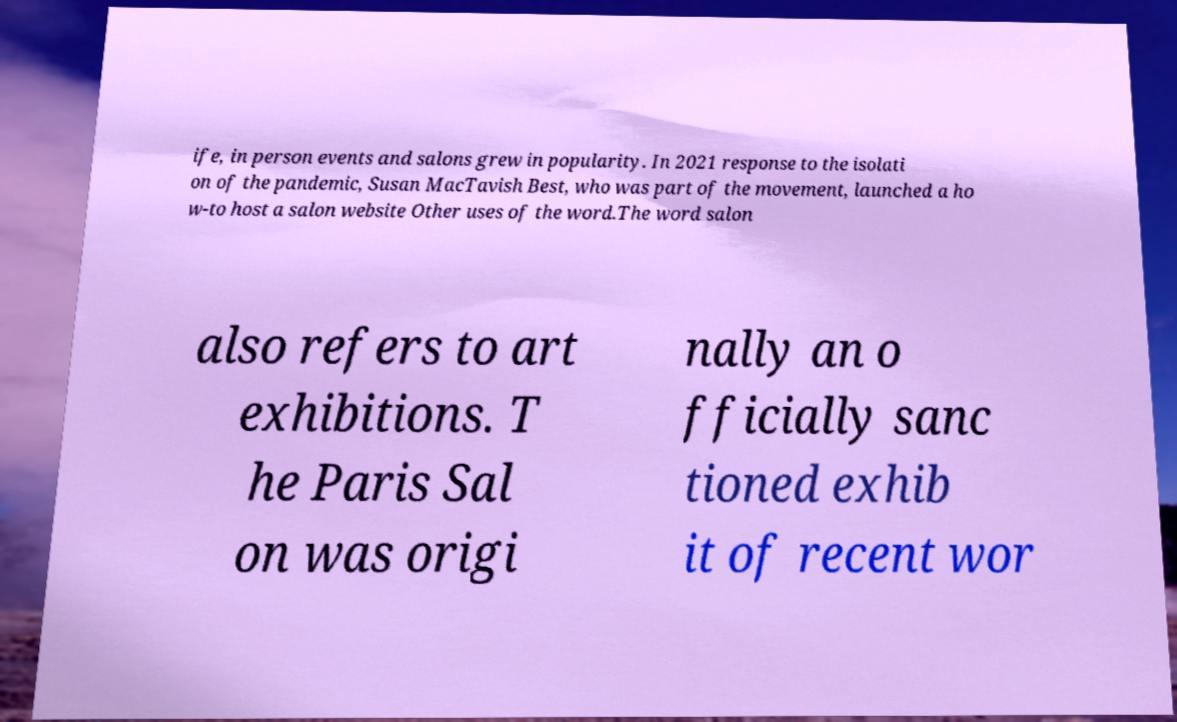I need the written content from this picture converted into text. Can you do that? ife, in person events and salons grew in popularity. In 2021 response to the isolati on of the pandemic, Susan MacTavish Best, who was part of the movement, launched a ho w-to host a salon website Other uses of the word.The word salon also refers to art exhibitions. T he Paris Sal on was origi nally an o fficially sanc tioned exhib it of recent wor 